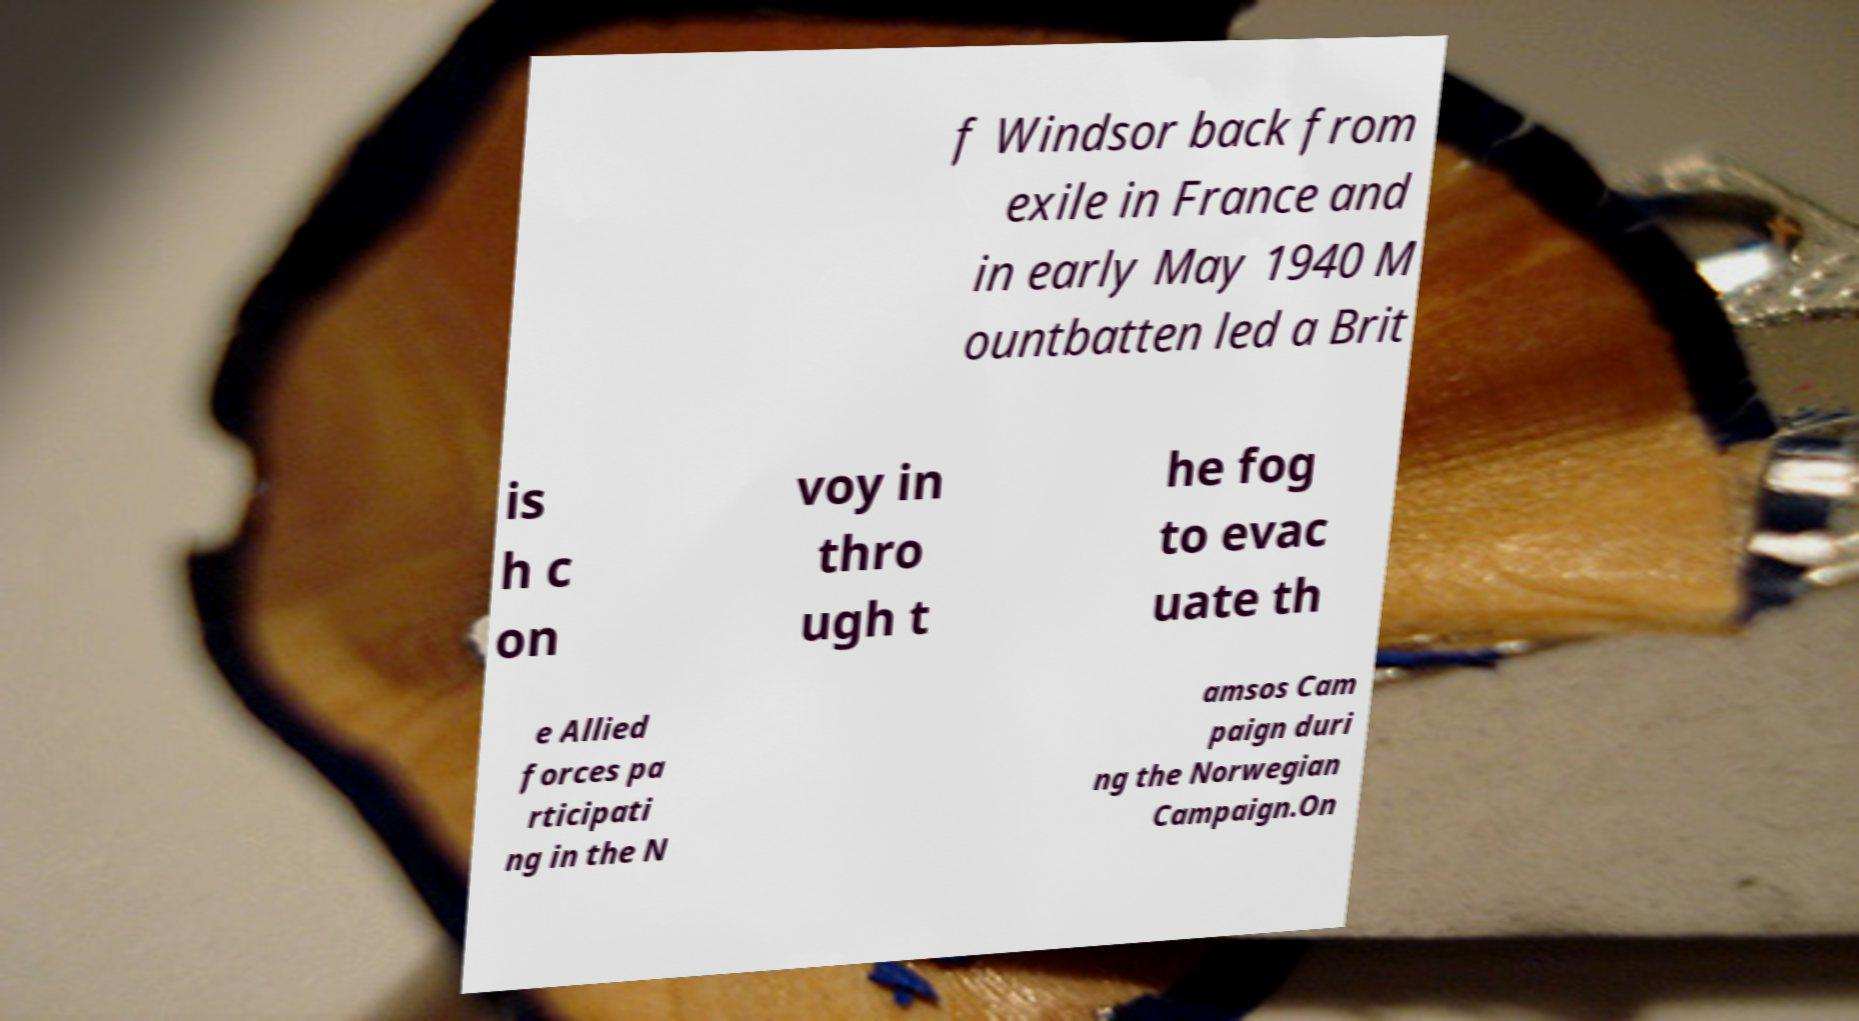I need the written content from this picture converted into text. Can you do that? f Windsor back from exile in France and in early May 1940 M ountbatten led a Brit is h c on voy in thro ugh t he fog to evac uate th e Allied forces pa rticipati ng in the N amsos Cam paign duri ng the Norwegian Campaign.On 